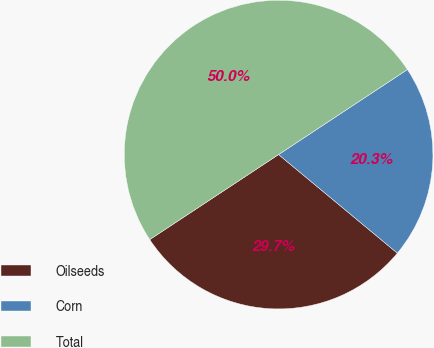<chart> <loc_0><loc_0><loc_500><loc_500><pie_chart><fcel>Oilseeds<fcel>Corn<fcel>Total<nl><fcel>29.69%<fcel>20.31%<fcel>50.0%<nl></chart> 